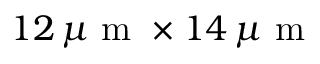<formula> <loc_0><loc_0><loc_500><loc_500>1 2 \, \mu m \times 1 4 \, \mu m</formula> 